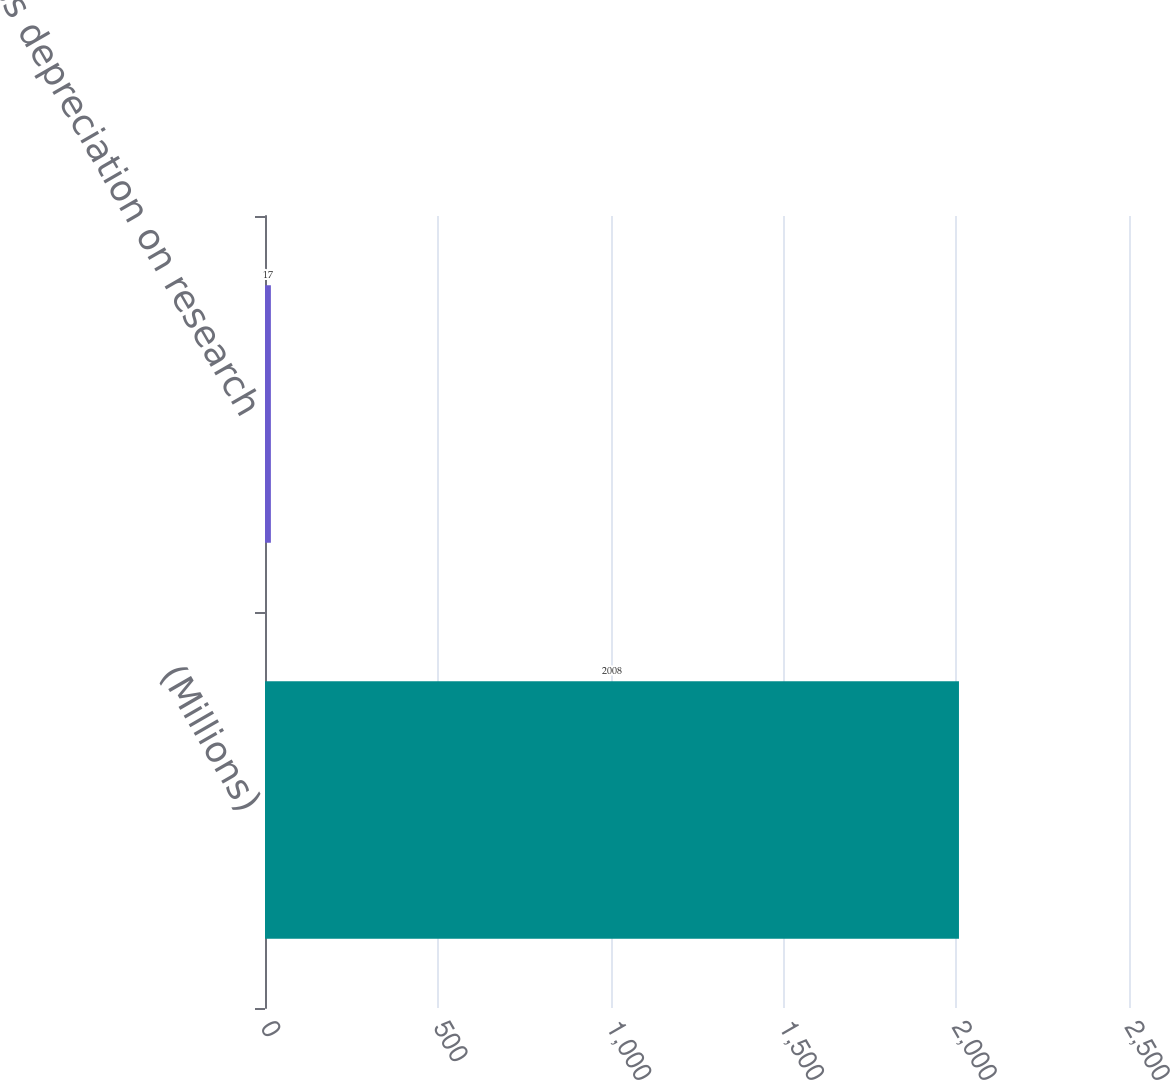Convert chart. <chart><loc_0><loc_0><loc_500><loc_500><bar_chart><fcel>(Millions)<fcel>Less depreciation on research<nl><fcel>2008<fcel>17<nl></chart> 